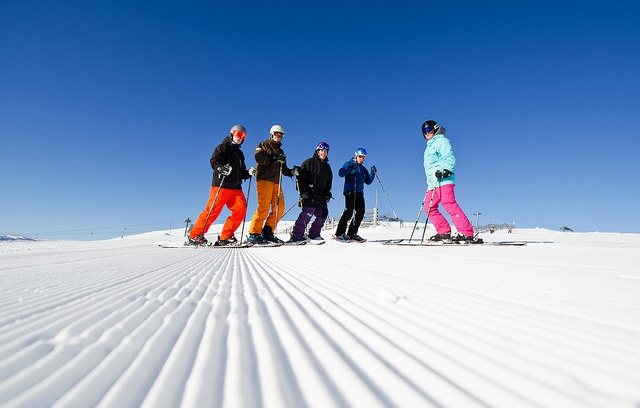Describe the objects in this image and their specific colors. I can see people in blue, black, red, and gray tones, people in blue, violet, lightblue, and black tones, people in blue, black, brown, and red tones, people in blue, black, navy, and gray tones, and people in blue, black, navy, and gray tones in this image. 